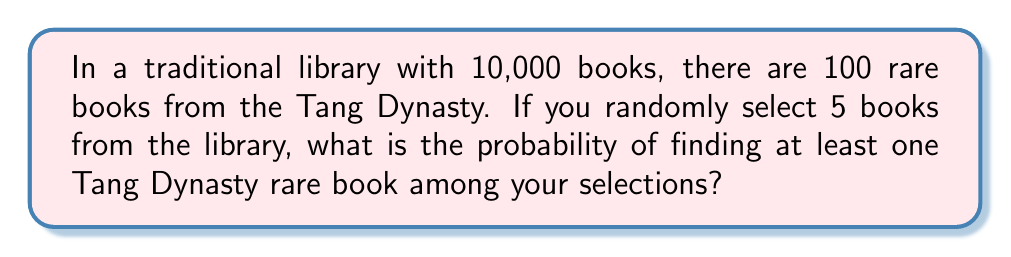Could you help me with this problem? Let's approach this step-by-step using the complement method:

1) First, let's calculate the probability of not selecting a Tang Dynasty book in one draw:
   $$P(\text{not Tang}) = \frac{10000 - 100}{10000} = \frac{9900}{10000} = 0.99$$

2) For all 5 selections to not be Tang Dynasty books, this needs to happen 5 times in a row:
   $$P(\text{all 5 not Tang}) = (0.99)^5 = 0.9509$$

3) The probability of finding at least one Tang Dynasty book is the complement of this:
   $$P(\text{at least one Tang}) = 1 - P(\text{all 5 not Tang})$$
   $$= 1 - 0.9509 = 0.0491$$

4) Convert to a percentage:
   $$0.0491 \times 100\% = 4.91\%$$

Therefore, the probability of finding at least one Tang Dynasty rare book among 5 random selections is approximately 4.91%.
Answer: 4.91% 